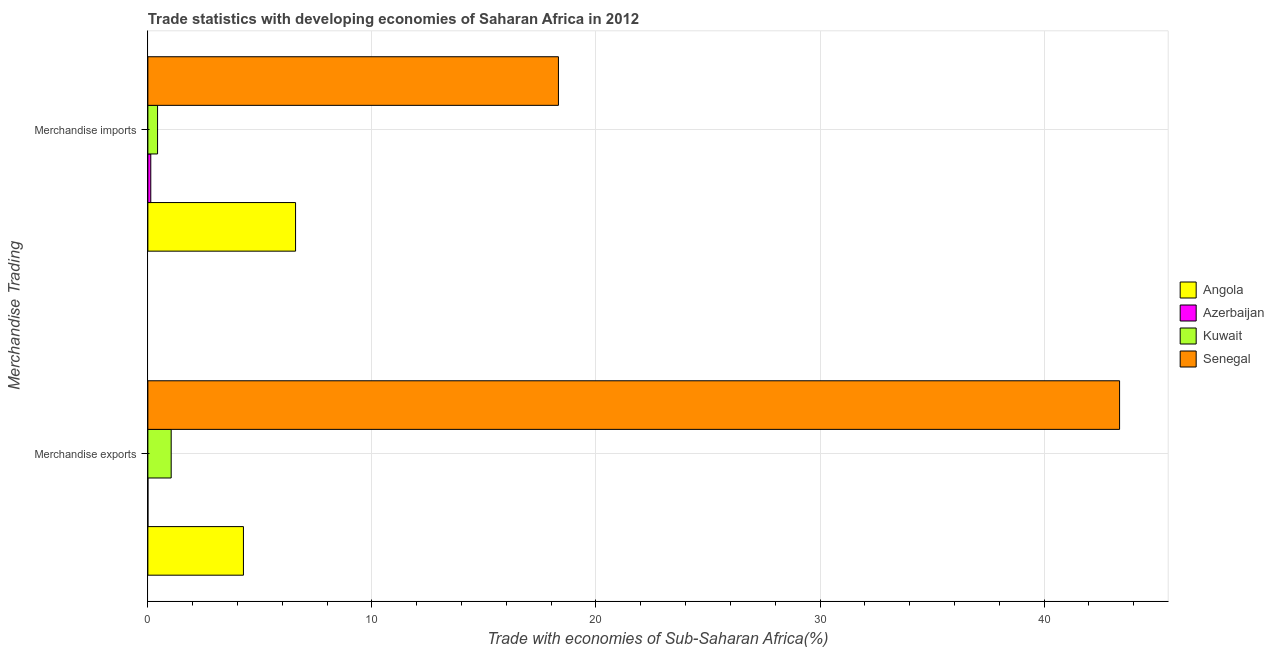How many groups of bars are there?
Your answer should be compact. 2. Are the number of bars per tick equal to the number of legend labels?
Offer a terse response. Yes. How many bars are there on the 1st tick from the top?
Your answer should be compact. 4. What is the label of the 1st group of bars from the top?
Offer a very short reply. Merchandise imports. What is the merchandise exports in Azerbaijan?
Offer a terse response. 0. Across all countries, what is the maximum merchandise exports?
Make the answer very short. 43.37. Across all countries, what is the minimum merchandise exports?
Offer a very short reply. 0. In which country was the merchandise exports maximum?
Your response must be concise. Senegal. In which country was the merchandise imports minimum?
Your response must be concise. Azerbaijan. What is the total merchandise exports in the graph?
Your answer should be compact. 48.68. What is the difference between the merchandise exports in Kuwait and that in Senegal?
Make the answer very short. -42.33. What is the difference between the merchandise imports in Kuwait and the merchandise exports in Azerbaijan?
Your answer should be compact. 0.43. What is the average merchandise imports per country?
Provide a succinct answer. 6.37. What is the difference between the merchandise exports and merchandise imports in Senegal?
Make the answer very short. 25.05. What is the ratio of the merchandise exports in Azerbaijan to that in Senegal?
Provide a succinct answer. 2.260648094846618e-5. What does the 3rd bar from the top in Merchandise imports represents?
Offer a very short reply. Azerbaijan. What does the 1st bar from the bottom in Merchandise imports represents?
Ensure brevity in your answer.  Angola. How many bars are there?
Ensure brevity in your answer.  8. Are all the bars in the graph horizontal?
Your answer should be very brief. Yes. What is the difference between two consecutive major ticks on the X-axis?
Make the answer very short. 10. Are the values on the major ticks of X-axis written in scientific E-notation?
Your response must be concise. No. Does the graph contain grids?
Offer a very short reply. Yes. Where does the legend appear in the graph?
Your answer should be very brief. Center right. How many legend labels are there?
Your answer should be very brief. 4. How are the legend labels stacked?
Give a very brief answer. Vertical. What is the title of the graph?
Your answer should be very brief. Trade statistics with developing economies of Saharan Africa in 2012. What is the label or title of the X-axis?
Give a very brief answer. Trade with economies of Sub-Saharan Africa(%). What is the label or title of the Y-axis?
Give a very brief answer. Merchandise Trading. What is the Trade with economies of Sub-Saharan Africa(%) of Angola in Merchandise exports?
Your answer should be very brief. 4.27. What is the Trade with economies of Sub-Saharan Africa(%) in Azerbaijan in Merchandise exports?
Your response must be concise. 0. What is the Trade with economies of Sub-Saharan Africa(%) of Kuwait in Merchandise exports?
Your answer should be compact. 1.04. What is the Trade with economies of Sub-Saharan Africa(%) in Senegal in Merchandise exports?
Provide a succinct answer. 43.37. What is the Trade with economies of Sub-Saharan Africa(%) in Angola in Merchandise imports?
Give a very brief answer. 6.59. What is the Trade with economies of Sub-Saharan Africa(%) of Azerbaijan in Merchandise imports?
Keep it short and to the point. 0.13. What is the Trade with economies of Sub-Saharan Africa(%) in Kuwait in Merchandise imports?
Make the answer very short. 0.43. What is the Trade with economies of Sub-Saharan Africa(%) in Senegal in Merchandise imports?
Give a very brief answer. 18.32. Across all Merchandise Trading, what is the maximum Trade with economies of Sub-Saharan Africa(%) in Angola?
Give a very brief answer. 6.59. Across all Merchandise Trading, what is the maximum Trade with economies of Sub-Saharan Africa(%) in Azerbaijan?
Your answer should be very brief. 0.13. Across all Merchandise Trading, what is the maximum Trade with economies of Sub-Saharan Africa(%) in Kuwait?
Provide a short and direct response. 1.04. Across all Merchandise Trading, what is the maximum Trade with economies of Sub-Saharan Africa(%) of Senegal?
Your response must be concise. 43.37. Across all Merchandise Trading, what is the minimum Trade with economies of Sub-Saharan Africa(%) of Angola?
Offer a very short reply. 4.27. Across all Merchandise Trading, what is the minimum Trade with economies of Sub-Saharan Africa(%) of Azerbaijan?
Give a very brief answer. 0. Across all Merchandise Trading, what is the minimum Trade with economies of Sub-Saharan Africa(%) in Kuwait?
Provide a short and direct response. 0.43. Across all Merchandise Trading, what is the minimum Trade with economies of Sub-Saharan Africa(%) of Senegal?
Make the answer very short. 18.32. What is the total Trade with economies of Sub-Saharan Africa(%) of Angola in the graph?
Offer a very short reply. 10.86. What is the total Trade with economies of Sub-Saharan Africa(%) of Azerbaijan in the graph?
Ensure brevity in your answer.  0.13. What is the total Trade with economies of Sub-Saharan Africa(%) in Kuwait in the graph?
Offer a very short reply. 1.47. What is the total Trade with economies of Sub-Saharan Africa(%) of Senegal in the graph?
Offer a terse response. 61.69. What is the difference between the Trade with economies of Sub-Saharan Africa(%) in Angola in Merchandise exports and that in Merchandise imports?
Give a very brief answer. -2.33. What is the difference between the Trade with economies of Sub-Saharan Africa(%) in Azerbaijan in Merchandise exports and that in Merchandise imports?
Your answer should be very brief. -0.13. What is the difference between the Trade with economies of Sub-Saharan Africa(%) of Kuwait in Merchandise exports and that in Merchandise imports?
Provide a succinct answer. 0.61. What is the difference between the Trade with economies of Sub-Saharan Africa(%) in Senegal in Merchandise exports and that in Merchandise imports?
Offer a terse response. 25.05. What is the difference between the Trade with economies of Sub-Saharan Africa(%) of Angola in Merchandise exports and the Trade with economies of Sub-Saharan Africa(%) of Azerbaijan in Merchandise imports?
Your response must be concise. 4.14. What is the difference between the Trade with economies of Sub-Saharan Africa(%) of Angola in Merchandise exports and the Trade with economies of Sub-Saharan Africa(%) of Kuwait in Merchandise imports?
Your response must be concise. 3.83. What is the difference between the Trade with economies of Sub-Saharan Africa(%) of Angola in Merchandise exports and the Trade with economies of Sub-Saharan Africa(%) of Senegal in Merchandise imports?
Keep it short and to the point. -14.06. What is the difference between the Trade with economies of Sub-Saharan Africa(%) in Azerbaijan in Merchandise exports and the Trade with economies of Sub-Saharan Africa(%) in Kuwait in Merchandise imports?
Provide a succinct answer. -0.43. What is the difference between the Trade with economies of Sub-Saharan Africa(%) of Azerbaijan in Merchandise exports and the Trade with economies of Sub-Saharan Africa(%) of Senegal in Merchandise imports?
Your response must be concise. -18.32. What is the difference between the Trade with economies of Sub-Saharan Africa(%) of Kuwait in Merchandise exports and the Trade with economies of Sub-Saharan Africa(%) of Senegal in Merchandise imports?
Offer a very short reply. -17.28. What is the average Trade with economies of Sub-Saharan Africa(%) in Angola per Merchandise Trading?
Your answer should be very brief. 5.43. What is the average Trade with economies of Sub-Saharan Africa(%) of Azerbaijan per Merchandise Trading?
Provide a short and direct response. 0.07. What is the average Trade with economies of Sub-Saharan Africa(%) in Kuwait per Merchandise Trading?
Keep it short and to the point. 0.74. What is the average Trade with economies of Sub-Saharan Africa(%) of Senegal per Merchandise Trading?
Make the answer very short. 30.85. What is the difference between the Trade with economies of Sub-Saharan Africa(%) of Angola and Trade with economies of Sub-Saharan Africa(%) of Azerbaijan in Merchandise exports?
Your answer should be very brief. 4.26. What is the difference between the Trade with economies of Sub-Saharan Africa(%) of Angola and Trade with economies of Sub-Saharan Africa(%) of Kuwait in Merchandise exports?
Give a very brief answer. 3.22. What is the difference between the Trade with economies of Sub-Saharan Africa(%) of Angola and Trade with economies of Sub-Saharan Africa(%) of Senegal in Merchandise exports?
Provide a short and direct response. -39.1. What is the difference between the Trade with economies of Sub-Saharan Africa(%) in Azerbaijan and Trade with economies of Sub-Saharan Africa(%) in Kuwait in Merchandise exports?
Ensure brevity in your answer.  -1.04. What is the difference between the Trade with economies of Sub-Saharan Africa(%) in Azerbaijan and Trade with economies of Sub-Saharan Africa(%) in Senegal in Merchandise exports?
Your answer should be compact. -43.37. What is the difference between the Trade with economies of Sub-Saharan Africa(%) of Kuwait and Trade with economies of Sub-Saharan Africa(%) of Senegal in Merchandise exports?
Your answer should be compact. -42.33. What is the difference between the Trade with economies of Sub-Saharan Africa(%) in Angola and Trade with economies of Sub-Saharan Africa(%) in Azerbaijan in Merchandise imports?
Provide a succinct answer. 6.46. What is the difference between the Trade with economies of Sub-Saharan Africa(%) of Angola and Trade with economies of Sub-Saharan Africa(%) of Kuwait in Merchandise imports?
Provide a succinct answer. 6.16. What is the difference between the Trade with economies of Sub-Saharan Africa(%) of Angola and Trade with economies of Sub-Saharan Africa(%) of Senegal in Merchandise imports?
Offer a terse response. -11.73. What is the difference between the Trade with economies of Sub-Saharan Africa(%) of Azerbaijan and Trade with economies of Sub-Saharan Africa(%) of Kuwait in Merchandise imports?
Provide a succinct answer. -0.3. What is the difference between the Trade with economies of Sub-Saharan Africa(%) in Azerbaijan and Trade with economies of Sub-Saharan Africa(%) in Senegal in Merchandise imports?
Your answer should be compact. -18.19. What is the difference between the Trade with economies of Sub-Saharan Africa(%) of Kuwait and Trade with economies of Sub-Saharan Africa(%) of Senegal in Merchandise imports?
Your answer should be compact. -17.89. What is the ratio of the Trade with economies of Sub-Saharan Africa(%) of Angola in Merchandise exports to that in Merchandise imports?
Provide a succinct answer. 0.65. What is the ratio of the Trade with economies of Sub-Saharan Africa(%) of Azerbaijan in Merchandise exports to that in Merchandise imports?
Give a very brief answer. 0.01. What is the ratio of the Trade with economies of Sub-Saharan Africa(%) of Kuwait in Merchandise exports to that in Merchandise imports?
Your answer should be very brief. 2.4. What is the ratio of the Trade with economies of Sub-Saharan Africa(%) in Senegal in Merchandise exports to that in Merchandise imports?
Offer a very short reply. 2.37. What is the difference between the highest and the second highest Trade with economies of Sub-Saharan Africa(%) in Angola?
Offer a terse response. 2.33. What is the difference between the highest and the second highest Trade with economies of Sub-Saharan Africa(%) of Azerbaijan?
Make the answer very short. 0.13. What is the difference between the highest and the second highest Trade with economies of Sub-Saharan Africa(%) in Kuwait?
Ensure brevity in your answer.  0.61. What is the difference between the highest and the second highest Trade with economies of Sub-Saharan Africa(%) in Senegal?
Your answer should be compact. 25.05. What is the difference between the highest and the lowest Trade with economies of Sub-Saharan Africa(%) of Angola?
Provide a succinct answer. 2.33. What is the difference between the highest and the lowest Trade with economies of Sub-Saharan Africa(%) in Azerbaijan?
Keep it short and to the point. 0.13. What is the difference between the highest and the lowest Trade with economies of Sub-Saharan Africa(%) of Kuwait?
Offer a terse response. 0.61. What is the difference between the highest and the lowest Trade with economies of Sub-Saharan Africa(%) of Senegal?
Make the answer very short. 25.05. 